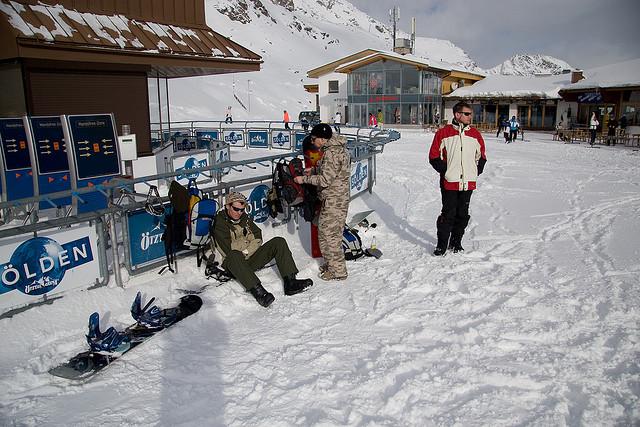What name is on the white banner?
Short answer required. Olden. Is this person doing something safe?
Keep it brief. Yes. Who is on the sponsors sign?
Answer briefly. Golden. Is there snow?
Keep it brief. Yes. What type of resort is this?
Concise answer only. Ski. 